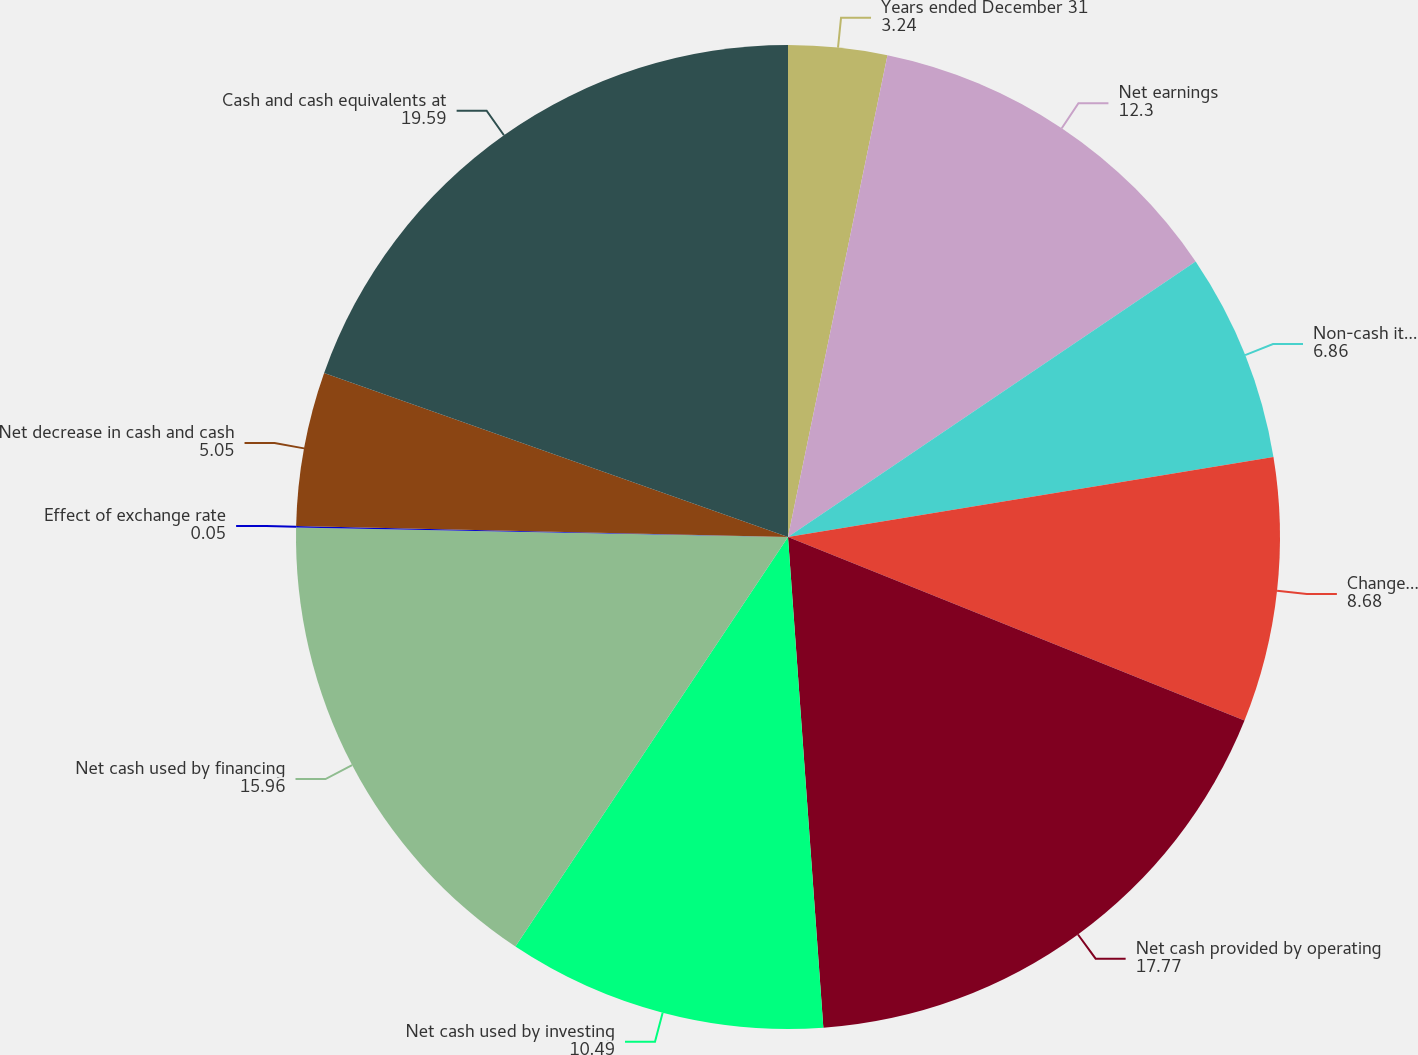<chart> <loc_0><loc_0><loc_500><loc_500><pie_chart><fcel>Years ended December 31<fcel>Net earnings<fcel>Non-cash items<fcel>Changes in working capital<fcel>Net cash provided by operating<fcel>Net cash used by investing<fcel>Net cash used by financing<fcel>Effect of exchange rate<fcel>Net decrease in cash and cash<fcel>Cash and cash equivalents at<nl><fcel>3.24%<fcel>12.3%<fcel>6.86%<fcel>8.68%<fcel>17.77%<fcel>10.49%<fcel>15.96%<fcel>0.05%<fcel>5.05%<fcel>19.59%<nl></chart> 